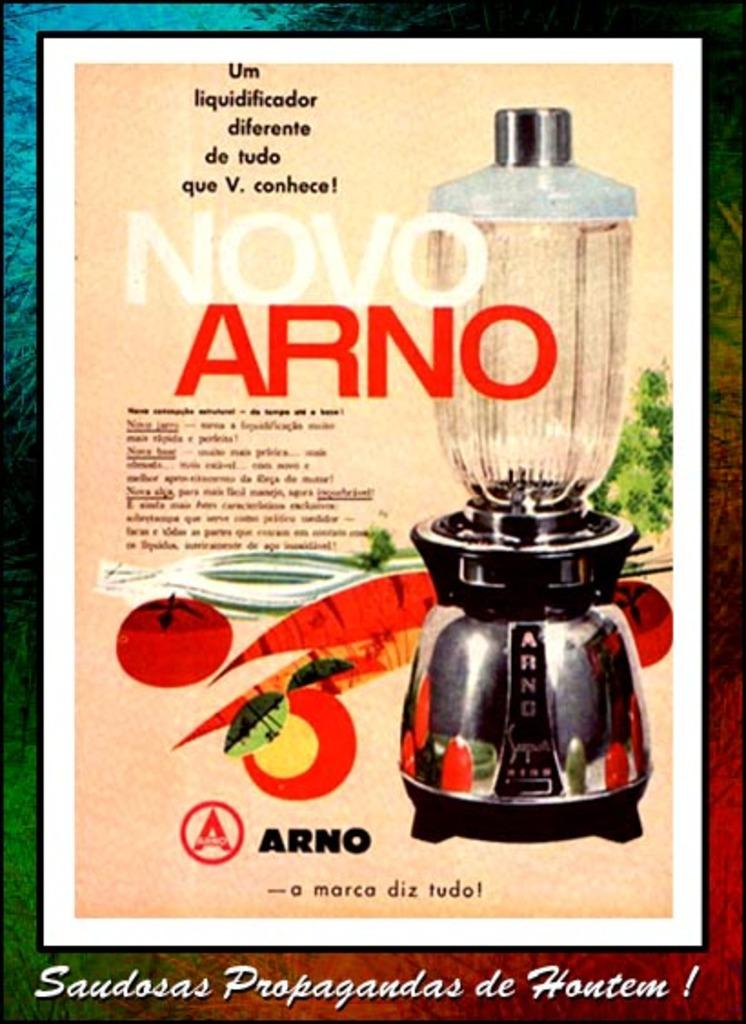Provide a one-sentence caption for the provided image. An advertisement for an Arno blender with pictures of fruit and vegetables on it. 